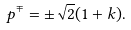<formula> <loc_0><loc_0><loc_500><loc_500>p ^ { \mp } = \pm \sqrt { 2 } ( 1 + k ) .</formula> 